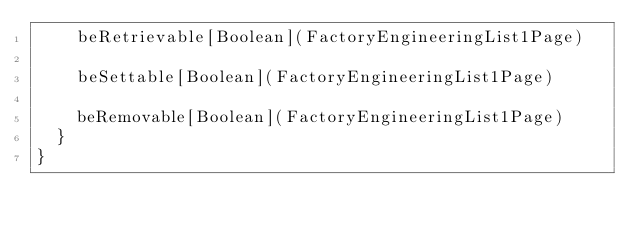Convert code to text. <code><loc_0><loc_0><loc_500><loc_500><_Scala_>    beRetrievable[Boolean](FactoryEngineeringList1Page)

    beSettable[Boolean](FactoryEngineeringList1Page)

    beRemovable[Boolean](FactoryEngineeringList1Page)
  }
}
</code> 